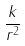<formula> <loc_0><loc_0><loc_500><loc_500>\frac { k } { r ^ { 2 } }</formula> 